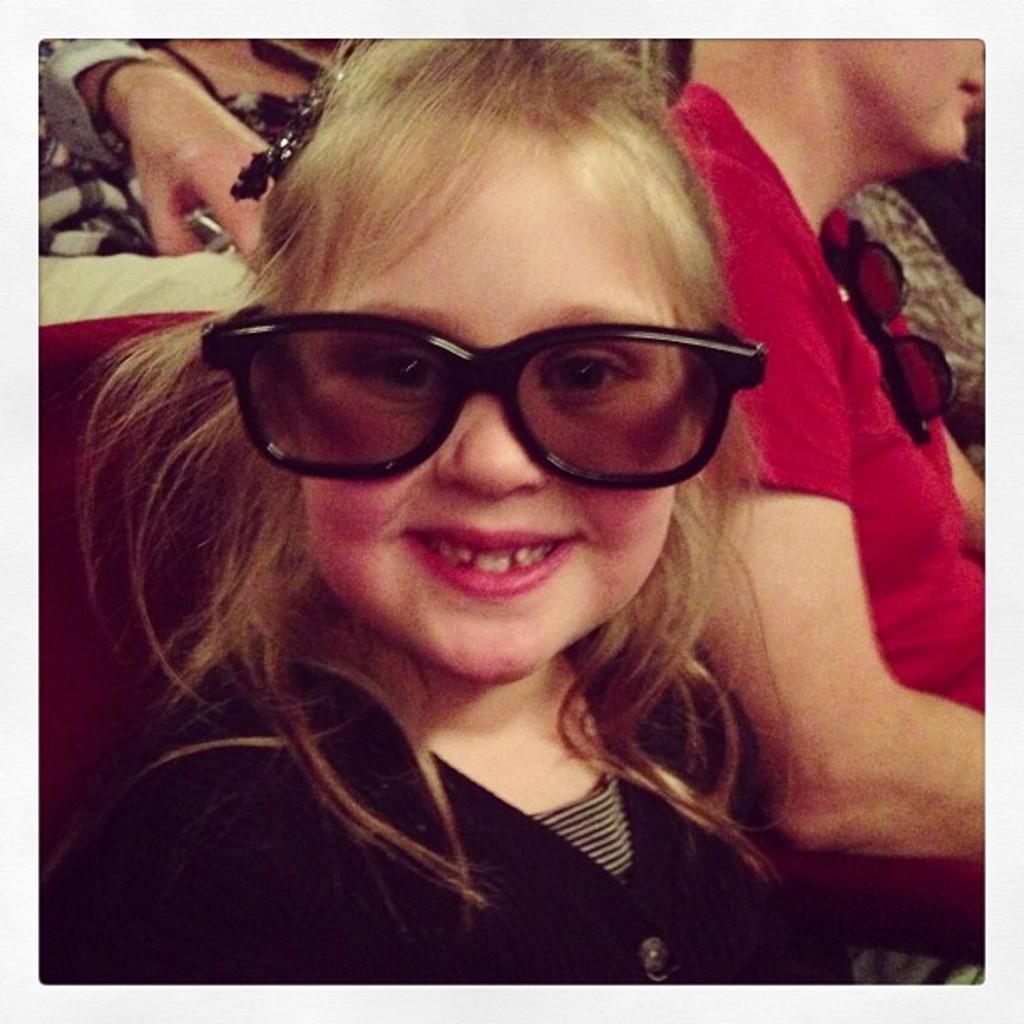Please provide a concise description of this image. In this picture we can see a girl wore goggles and smiling. In the background we can see some people. 